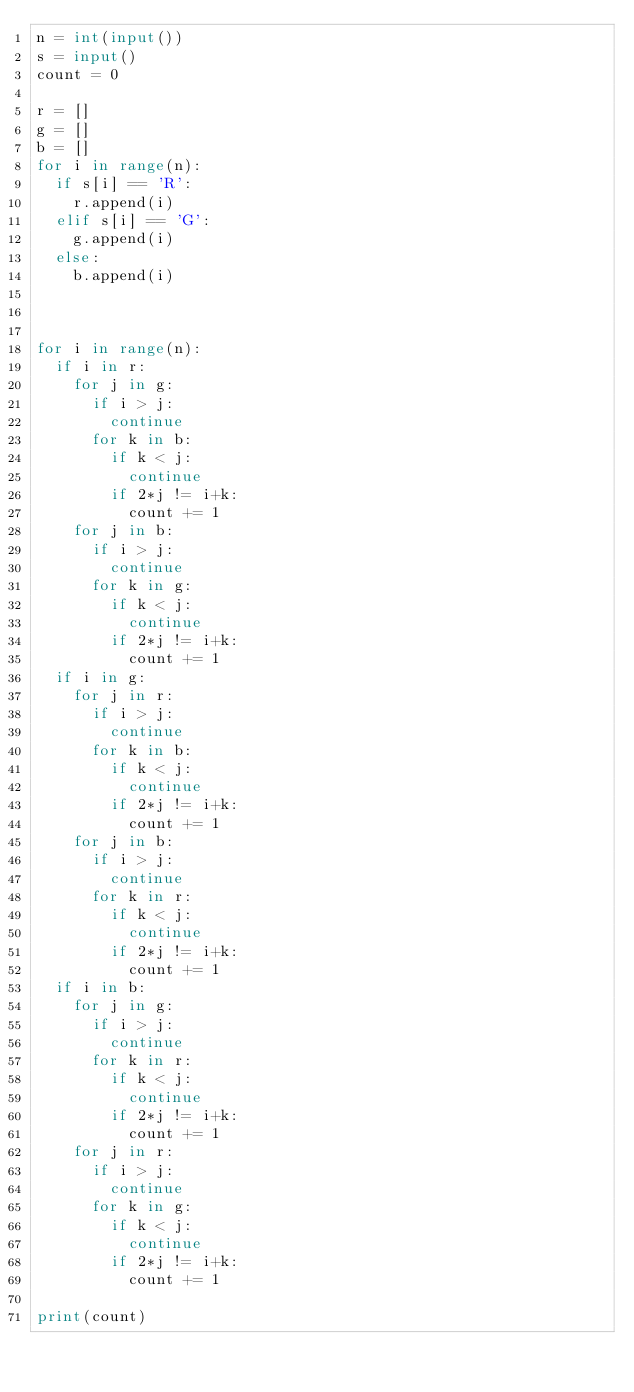<code> <loc_0><loc_0><loc_500><loc_500><_Python_>n = int(input())
s = input()
count = 0

r = []
g = []
b = []
for i in range(n):
  if s[i] == 'R':
    r.append(i)
  elif s[i] == 'G':
    g.append(i)
  else:
    b.append(i)
    


for i in range(n):
  if i in r:
    for j in g:
      if i > j:
        continue
      for k in b:
        if k < j:
          continue
        if 2*j != i+k:
          count += 1
    for j in b:
      if i > j:
        continue
      for k in g:
        if k < j:
          continue
        if 2*j != i+k:
          count += 1      
  if i in g:
    for j in r:
      if i > j:
        continue
      for k in b:
        if k < j:
          continue
        if 2*j != i+k:
          count += 1
    for j in b:
      if i > j:
        continue
      for k in r:
        if k < j:
          continue
        if 2*j != i+k:
          count += 1
  if i in b:
    for j in g:
      if i > j:
        continue
      for k in r:
        if k < j:
          continue
        if 2*j != i+k:
          count += 1
    for j in r:
      if i > j:
        continue
      for k in g:
        if k < j:
          continue
        if 2*j != i+k:
          count += 1

print(count)</code> 